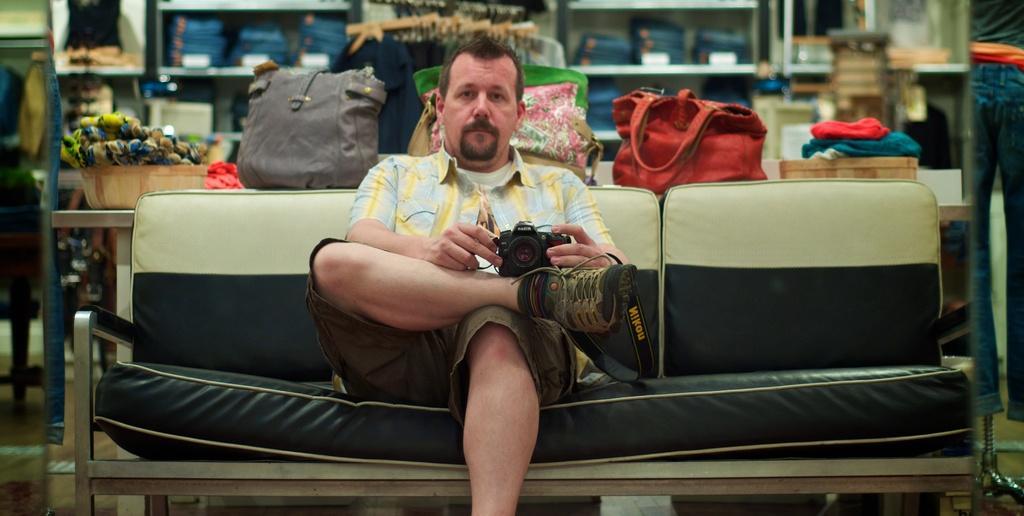Could you give a brief overview of what you see in this image? This person is sitting on a white and black couch and holding camera. Background on table there are bags, container with clothes and this racks are filled with clothes. Far there is a jeans. 